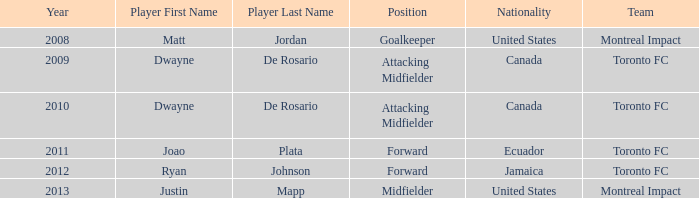Who was the canadian player that rose to prominence after 2009? Dwayne De Rosario Category:Articles with hCards. Could you help me parse every detail presented in this table? {'header': ['Year', 'Player First Name', 'Player Last Name', 'Position', 'Nationality', 'Team'], 'rows': [['2008', 'Matt', 'Jordan', 'Goalkeeper', 'United States', 'Montreal Impact'], ['2009', 'Dwayne', 'De Rosario', 'Attacking Midfielder', 'Canada', 'Toronto FC'], ['2010', 'Dwayne', 'De Rosario', 'Attacking Midfielder', 'Canada', 'Toronto FC'], ['2011', 'Joao', 'Plata', 'Forward', 'Ecuador', 'Toronto FC'], ['2012', 'Ryan', 'Johnson', 'Forward', 'Jamaica', 'Toronto FC'], ['2013', 'Justin', 'Mapp', 'Midfielder', 'United States', 'Montreal Impact']]} 